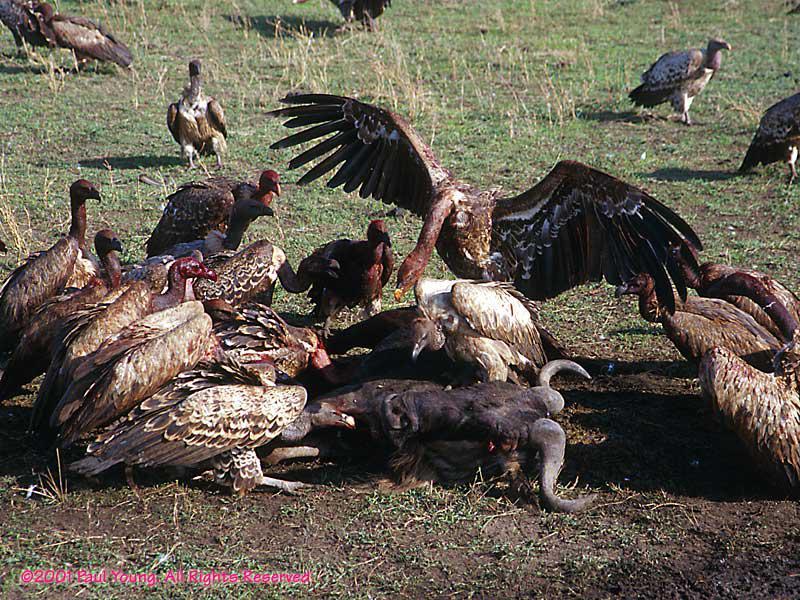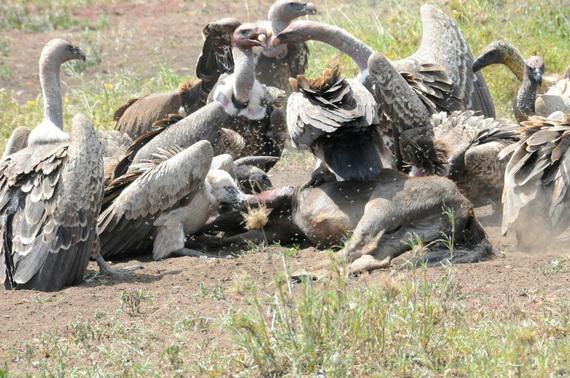The first image is the image on the left, the second image is the image on the right. Examine the images to the left and right. Is the description "The vultures in the image on the right are squabbling over bloody remains in an arid, brown landscape with no green grass." accurate? Answer yes or no. No. The first image is the image on the left, the second image is the image on the right. Considering the images on both sides, is "There are more than 5 vulture eating an animal with a set of horns that are visible." valid? Answer yes or no. Yes. 